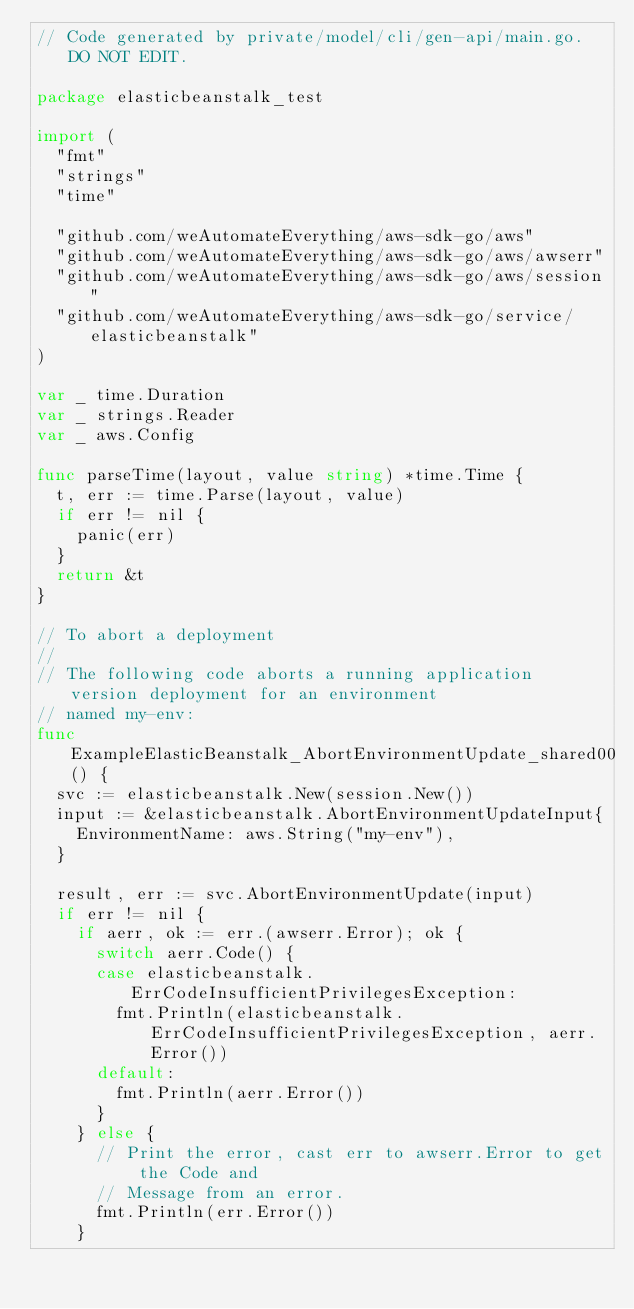Convert code to text. <code><loc_0><loc_0><loc_500><loc_500><_Go_>// Code generated by private/model/cli/gen-api/main.go. DO NOT EDIT.

package elasticbeanstalk_test

import (
	"fmt"
	"strings"
	"time"

	"github.com/weAutomateEverything/aws-sdk-go/aws"
	"github.com/weAutomateEverything/aws-sdk-go/aws/awserr"
	"github.com/weAutomateEverything/aws-sdk-go/aws/session"
	"github.com/weAutomateEverything/aws-sdk-go/service/elasticbeanstalk"
)

var _ time.Duration
var _ strings.Reader
var _ aws.Config

func parseTime(layout, value string) *time.Time {
	t, err := time.Parse(layout, value)
	if err != nil {
		panic(err)
	}
	return &t
}

// To abort a deployment
//
// The following code aborts a running application version deployment for an environment
// named my-env:
func ExampleElasticBeanstalk_AbortEnvironmentUpdate_shared00() {
	svc := elasticbeanstalk.New(session.New())
	input := &elasticbeanstalk.AbortEnvironmentUpdateInput{
		EnvironmentName: aws.String("my-env"),
	}

	result, err := svc.AbortEnvironmentUpdate(input)
	if err != nil {
		if aerr, ok := err.(awserr.Error); ok {
			switch aerr.Code() {
			case elasticbeanstalk.ErrCodeInsufficientPrivilegesException:
				fmt.Println(elasticbeanstalk.ErrCodeInsufficientPrivilegesException, aerr.Error())
			default:
				fmt.Println(aerr.Error())
			}
		} else {
			// Print the error, cast err to awserr.Error to get the Code and
			// Message from an error.
			fmt.Println(err.Error())
		}</code> 